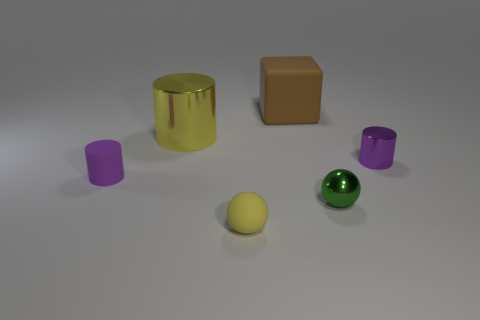Add 3 yellow things. How many objects exist? 9 Subtract all cubes. How many objects are left? 5 Subtract all big yellow shiny spheres. Subtract all purple metallic objects. How many objects are left? 5 Add 3 yellow spheres. How many yellow spheres are left? 4 Add 4 green objects. How many green objects exist? 5 Subtract 0 yellow blocks. How many objects are left? 6 